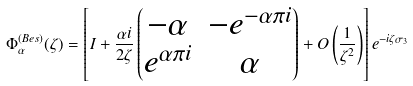<formula> <loc_0><loc_0><loc_500><loc_500>\Phi ^ { ( B e s ) } _ { \alpha } ( \zeta ) = \left [ I + \frac { \alpha i } { 2 \zeta } \begin{pmatrix} - \alpha & - e ^ { - \alpha \pi i } \\ e ^ { \alpha \pi i } & \alpha \end{pmatrix} + O \left ( \frac { 1 } { \zeta ^ { 2 } } \right ) \right ] e ^ { - i \zeta \sigma _ { 3 } }</formula> 